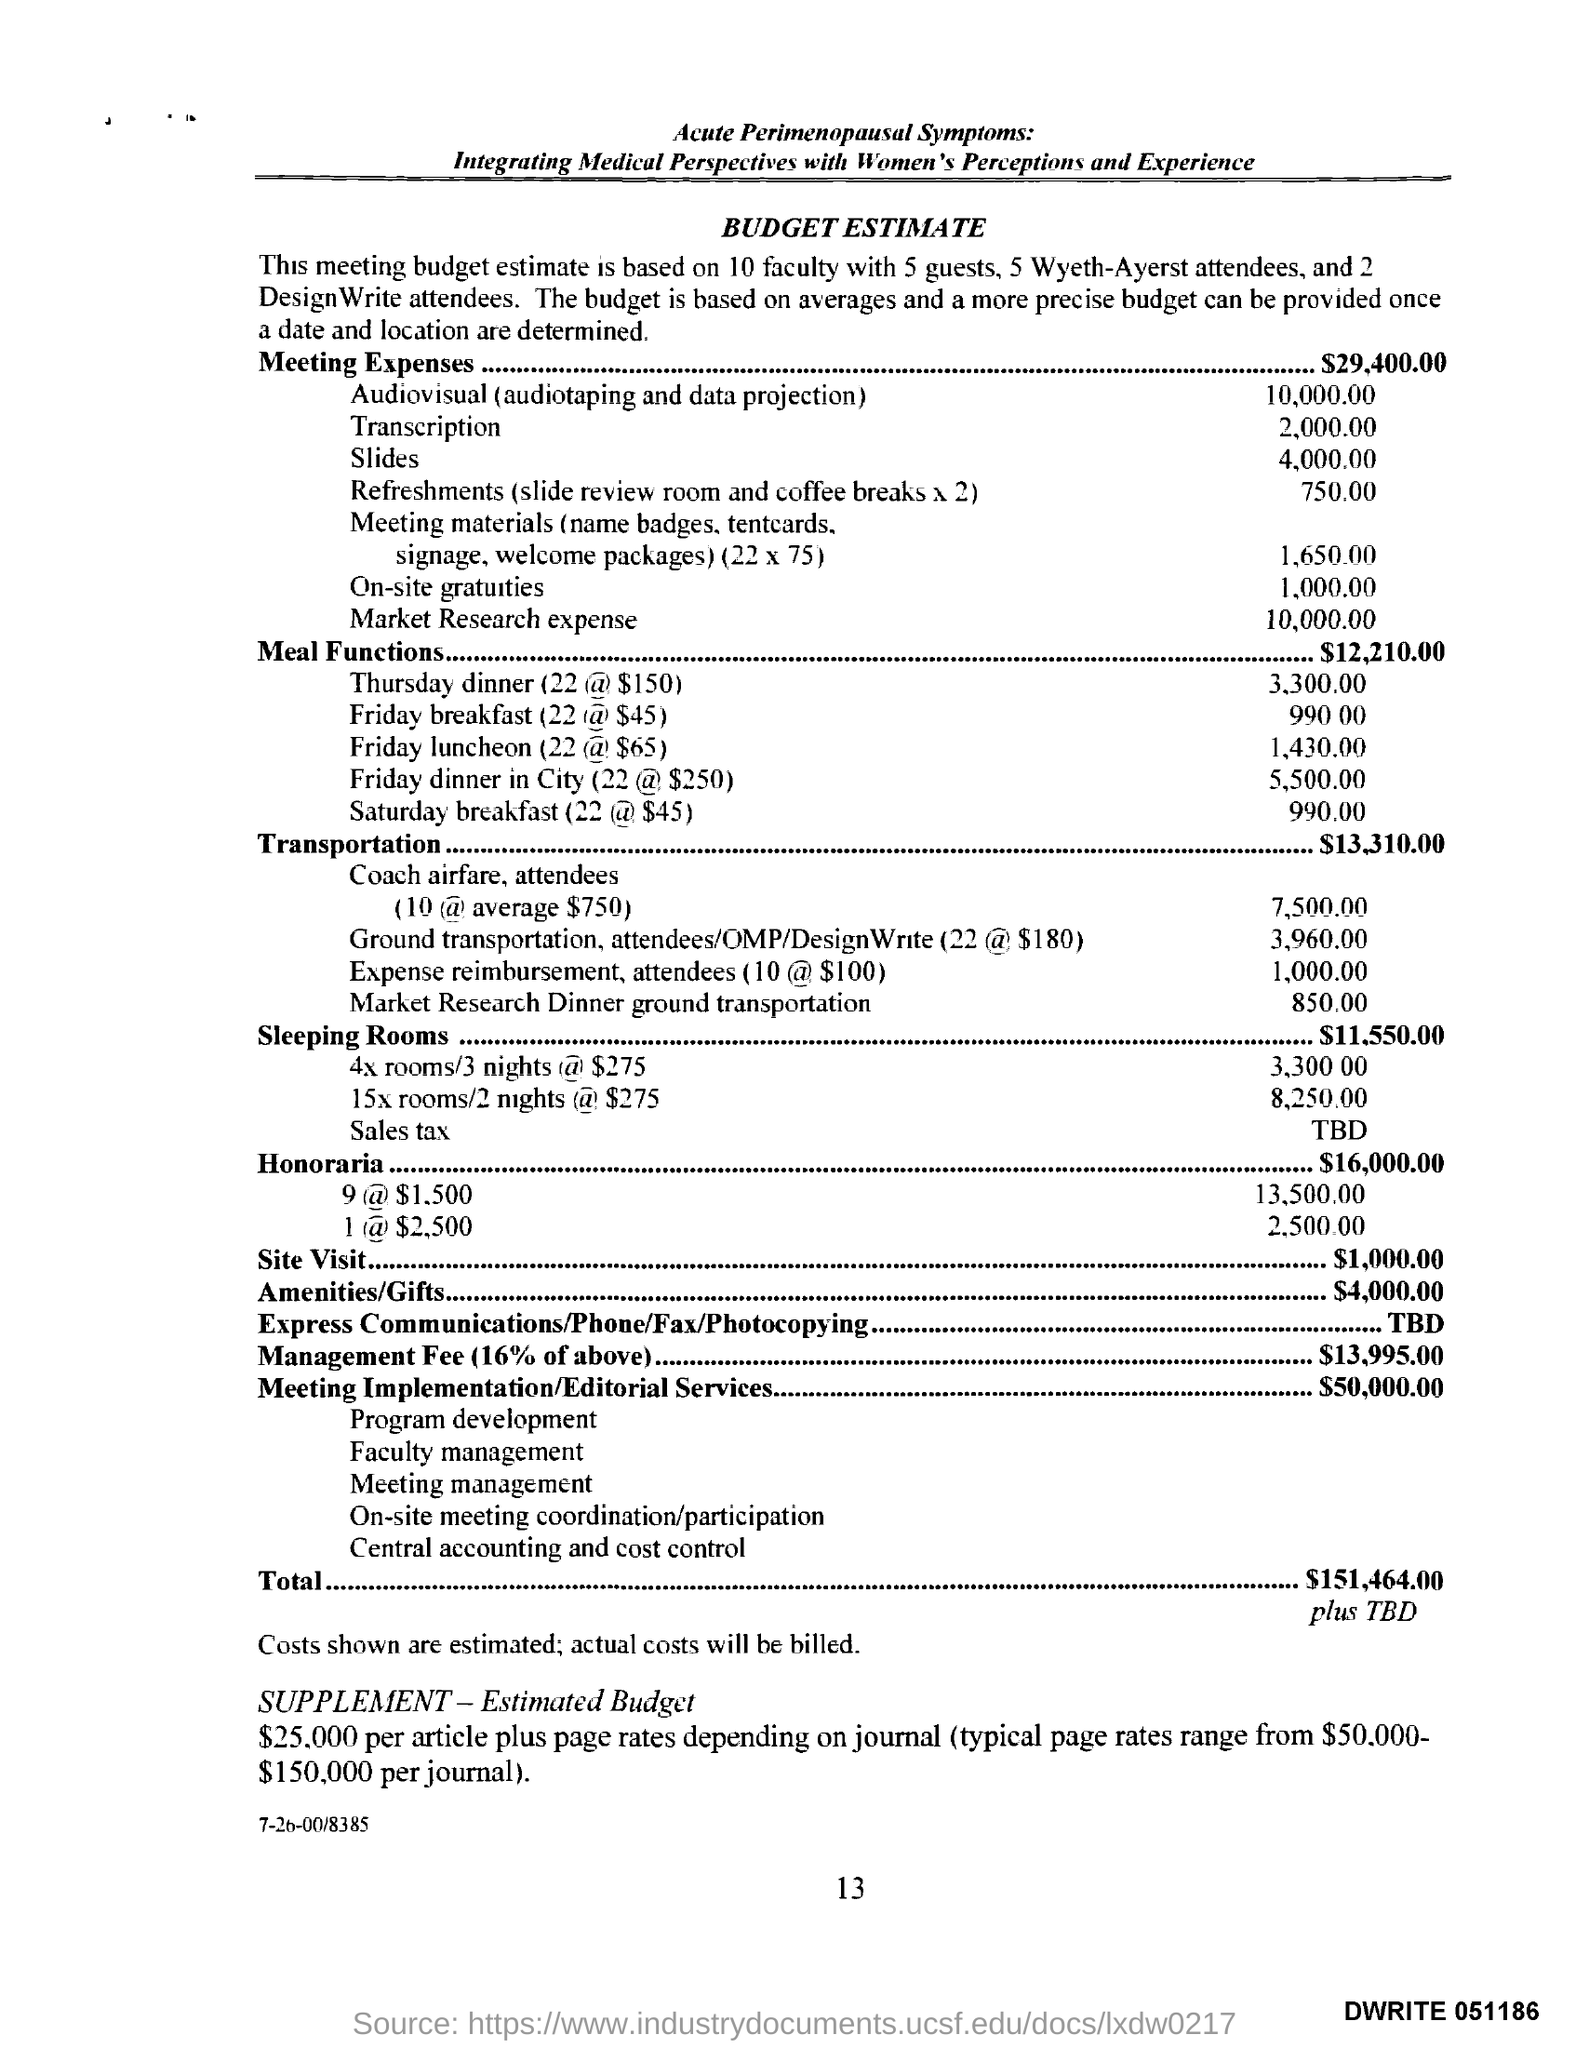What is this document refers to ?
Offer a terse response. Budget Estimate. What is the amount for the meal functions ?
Your answer should be very brief. $12,210.00. How much amount is mentioned for sleeping rooms ?
Provide a short and direct response. 11,550.00. 